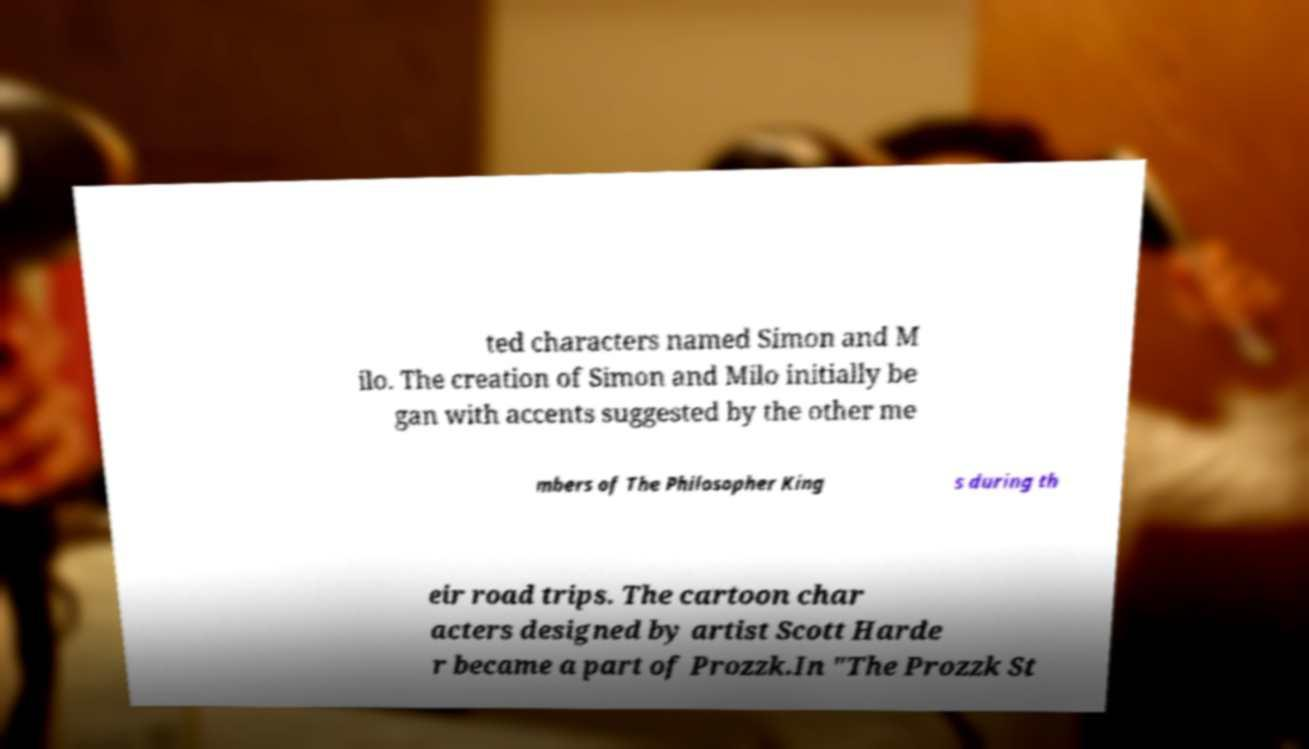Could you extract and type out the text from this image? ted characters named Simon and M ilo. The creation of Simon and Milo initially be gan with accents suggested by the other me mbers of The Philosopher King s during th eir road trips. The cartoon char acters designed by artist Scott Harde r became a part of Prozzk.In "The Prozzk St 